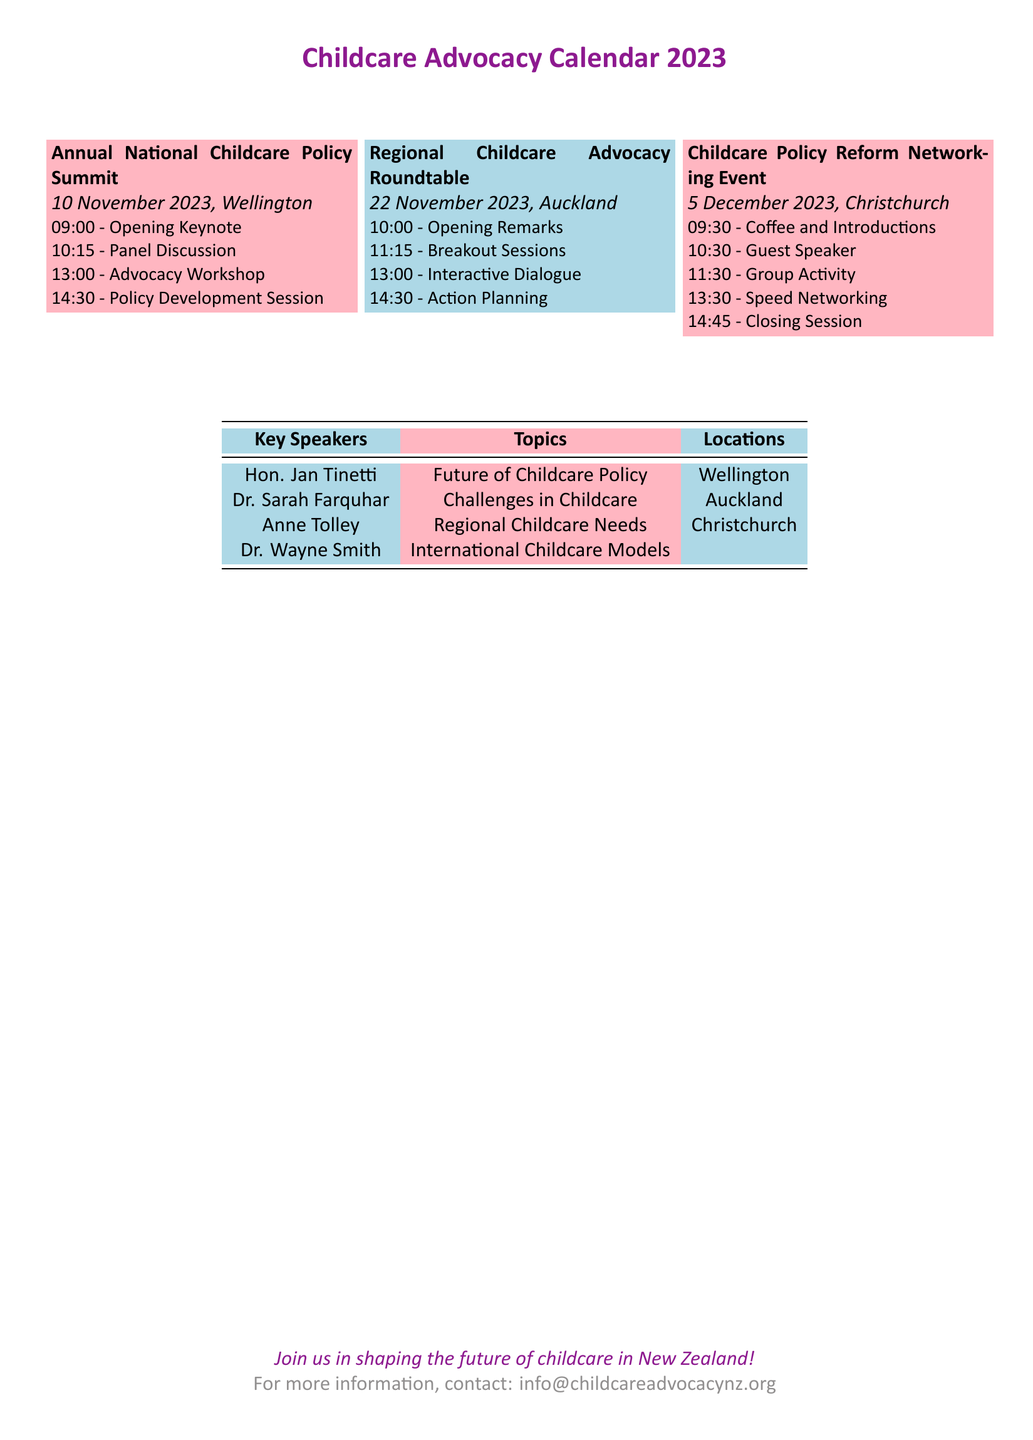What is the date of the Annual National Childcare Policy Summit? The date is clearly stated in the document as 10 November 2023.
Answer: 10 November 2023 What time does the Advocacy Workshop begin? The time for the Advocacy Workshop is listed as 13:00 in the agenda for the Annual National Childcare Policy Summit.
Answer: 13:00 Who is the guest speaker at the Childcare Policy Reform Networking Event? The document specifies a Guest Speaker session but does not name the guest speaker.
Answer: Not specified What location is the Regional Childcare Advocacy Roundtable held? The location is explicitly stated in the title as Auckland.
Answer: Auckland How many sessions are listed for the Annual National Childcare Policy Summit? The summit agenda includes four sessions: Opening Keynote, Panel Discussion, Advocacy Workshop, and Policy Development Session.
Answer: Four Which speaker discusses Challenges in Childcare? This information requires looking at the Key Speakers table, where Dr. Sarah Farquhar is identified with that topic.
Answer: Dr. Sarah Farquhar What is the closing session time for the Childcare Policy Reform Networking Event? The time for the Closing Session is mentioned as 14:45 in the event schedule.
Answer: 14:45 What color is used for the Regional Childcare Advocacy Roundtable box? This information is shown in the color coding of the document, where light blue is used for this roundtable.
Answer: Light blue What is the purpose of the document? The document serves as a calendar for upcoming childcare advocacy events and meetings related to policy discussions.
Answer: Calendar for advocacy events 